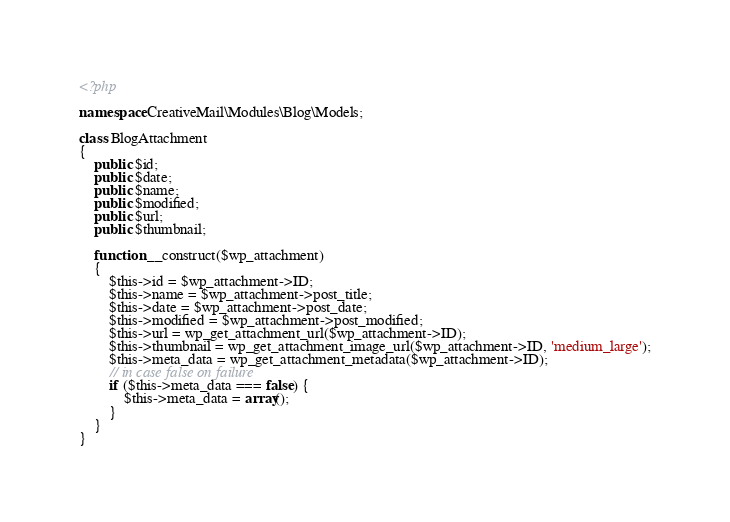Convert code to text. <code><loc_0><loc_0><loc_500><loc_500><_PHP_><?php

namespace CreativeMail\Modules\Blog\Models;

class BlogAttachment
{
    public $id;
    public $date;
    public $name;
    public $modified;
    public $url;
    public $thumbnail;

    function __construct($wp_attachment)
    {
        $this->id = $wp_attachment->ID;
        $this->name = $wp_attachment->post_title;
        $this->date = $wp_attachment->post_date;
        $this->modified = $wp_attachment->post_modified;
        $this->url = wp_get_attachment_url($wp_attachment->ID);
        $this->thumbnail = wp_get_attachment_image_url($wp_attachment->ID, 'medium_large');
        $this->meta_data = wp_get_attachment_metadata($wp_attachment->ID);
        // in case false on failure
        if ($this->meta_data === false) {
            $this->meta_data = array();
        }
    }
}
</code> 